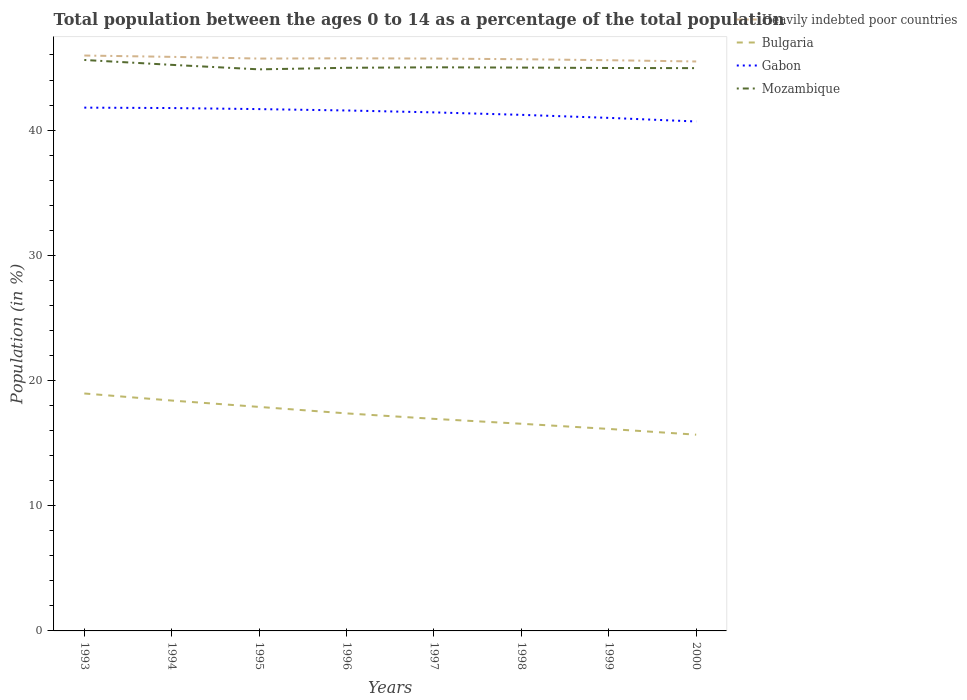How many different coloured lines are there?
Provide a short and direct response. 4. Across all years, what is the maximum percentage of the population ages 0 to 14 in Mozambique?
Your response must be concise. 44.85. In which year was the percentage of the population ages 0 to 14 in Bulgaria maximum?
Give a very brief answer. 2000. What is the total percentage of the population ages 0 to 14 in Heavily indebted poor countries in the graph?
Your answer should be very brief. 0.13. What is the difference between the highest and the second highest percentage of the population ages 0 to 14 in Heavily indebted poor countries?
Offer a very short reply. 0.47. Is the percentage of the population ages 0 to 14 in Bulgaria strictly greater than the percentage of the population ages 0 to 14 in Gabon over the years?
Give a very brief answer. Yes. What is the difference between two consecutive major ticks on the Y-axis?
Ensure brevity in your answer.  10. Are the values on the major ticks of Y-axis written in scientific E-notation?
Provide a short and direct response. No. Does the graph contain any zero values?
Provide a short and direct response. No. Does the graph contain grids?
Give a very brief answer. No. How are the legend labels stacked?
Your answer should be compact. Vertical. What is the title of the graph?
Ensure brevity in your answer.  Total population between the ages 0 to 14 as a percentage of the total population. Does "Jordan" appear as one of the legend labels in the graph?
Offer a very short reply. No. What is the Population (in %) of Heavily indebted poor countries in 1993?
Offer a terse response. 45.95. What is the Population (in %) of Bulgaria in 1993?
Offer a very short reply. 18.96. What is the Population (in %) in Gabon in 1993?
Provide a short and direct response. 41.79. What is the Population (in %) of Mozambique in 1993?
Provide a short and direct response. 45.6. What is the Population (in %) of Heavily indebted poor countries in 1994?
Ensure brevity in your answer.  45.85. What is the Population (in %) in Bulgaria in 1994?
Your answer should be compact. 18.4. What is the Population (in %) of Gabon in 1994?
Give a very brief answer. 41.76. What is the Population (in %) in Mozambique in 1994?
Provide a short and direct response. 45.21. What is the Population (in %) in Heavily indebted poor countries in 1995?
Give a very brief answer. 45.71. What is the Population (in %) of Bulgaria in 1995?
Provide a succinct answer. 17.89. What is the Population (in %) of Gabon in 1995?
Provide a short and direct response. 41.68. What is the Population (in %) of Mozambique in 1995?
Provide a short and direct response. 44.85. What is the Population (in %) of Heavily indebted poor countries in 1996?
Make the answer very short. 45.73. What is the Population (in %) of Bulgaria in 1996?
Provide a short and direct response. 17.37. What is the Population (in %) of Gabon in 1996?
Make the answer very short. 41.57. What is the Population (in %) in Mozambique in 1996?
Keep it short and to the point. 44.98. What is the Population (in %) of Heavily indebted poor countries in 1997?
Keep it short and to the point. 45.71. What is the Population (in %) of Bulgaria in 1997?
Provide a short and direct response. 16.94. What is the Population (in %) of Gabon in 1997?
Your answer should be very brief. 41.41. What is the Population (in %) of Mozambique in 1997?
Provide a short and direct response. 45.01. What is the Population (in %) of Heavily indebted poor countries in 1998?
Your response must be concise. 45.66. What is the Population (in %) of Bulgaria in 1998?
Give a very brief answer. 16.55. What is the Population (in %) in Gabon in 1998?
Provide a short and direct response. 41.22. What is the Population (in %) of Mozambique in 1998?
Make the answer very short. 44.99. What is the Population (in %) in Heavily indebted poor countries in 1999?
Offer a very short reply. 45.58. What is the Population (in %) of Bulgaria in 1999?
Keep it short and to the point. 16.13. What is the Population (in %) of Gabon in 1999?
Your answer should be compact. 40.98. What is the Population (in %) of Mozambique in 1999?
Make the answer very short. 44.96. What is the Population (in %) in Heavily indebted poor countries in 2000?
Provide a short and direct response. 45.48. What is the Population (in %) in Bulgaria in 2000?
Make the answer very short. 15.67. What is the Population (in %) of Gabon in 2000?
Your response must be concise. 40.69. What is the Population (in %) of Mozambique in 2000?
Your answer should be compact. 44.95. Across all years, what is the maximum Population (in %) of Heavily indebted poor countries?
Ensure brevity in your answer.  45.95. Across all years, what is the maximum Population (in %) in Bulgaria?
Your answer should be very brief. 18.96. Across all years, what is the maximum Population (in %) of Gabon?
Your answer should be very brief. 41.79. Across all years, what is the maximum Population (in %) in Mozambique?
Make the answer very short. 45.6. Across all years, what is the minimum Population (in %) in Heavily indebted poor countries?
Offer a very short reply. 45.48. Across all years, what is the minimum Population (in %) in Bulgaria?
Provide a short and direct response. 15.67. Across all years, what is the minimum Population (in %) of Gabon?
Offer a very short reply. 40.69. Across all years, what is the minimum Population (in %) in Mozambique?
Make the answer very short. 44.85. What is the total Population (in %) of Heavily indebted poor countries in the graph?
Provide a short and direct response. 365.68. What is the total Population (in %) of Bulgaria in the graph?
Offer a terse response. 137.91. What is the total Population (in %) in Gabon in the graph?
Give a very brief answer. 331.09. What is the total Population (in %) in Mozambique in the graph?
Give a very brief answer. 360.55. What is the difference between the Population (in %) in Heavily indebted poor countries in 1993 and that in 1994?
Offer a very short reply. 0.11. What is the difference between the Population (in %) of Bulgaria in 1993 and that in 1994?
Keep it short and to the point. 0.56. What is the difference between the Population (in %) of Gabon in 1993 and that in 1994?
Make the answer very short. 0.03. What is the difference between the Population (in %) of Mozambique in 1993 and that in 1994?
Provide a short and direct response. 0.39. What is the difference between the Population (in %) of Heavily indebted poor countries in 1993 and that in 1995?
Make the answer very short. 0.24. What is the difference between the Population (in %) of Bulgaria in 1993 and that in 1995?
Make the answer very short. 1.07. What is the difference between the Population (in %) of Gabon in 1993 and that in 1995?
Your answer should be very brief. 0.12. What is the difference between the Population (in %) in Mozambique in 1993 and that in 1995?
Offer a terse response. 0.75. What is the difference between the Population (in %) of Heavily indebted poor countries in 1993 and that in 1996?
Your response must be concise. 0.22. What is the difference between the Population (in %) in Bulgaria in 1993 and that in 1996?
Your response must be concise. 1.59. What is the difference between the Population (in %) of Gabon in 1993 and that in 1996?
Your response must be concise. 0.23. What is the difference between the Population (in %) in Mozambique in 1993 and that in 1996?
Offer a terse response. 0.62. What is the difference between the Population (in %) in Heavily indebted poor countries in 1993 and that in 1997?
Provide a short and direct response. 0.24. What is the difference between the Population (in %) in Bulgaria in 1993 and that in 1997?
Give a very brief answer. 2.03. What is the difference between the Population (in %) in Gabon in 1993 and that in 1997?
Offer a very short reply. 0.38. What is the difference between the Population (in %) of Mozambique in 1993 and that in 1997?
Keep it short and to the point. 0.59. What is the difference between the Population (in %) of Heavily indebted poor countries in 1993 and that in 1998?
Give a very brief answer. 0.29. What is the difference between the Population (in %) of Bulgaria in 1993 and that in 1998?
Ensure brevity in your answer.  2.42. What is the difference between the Population (in %) in Gabon in 1993 and that in 1998?
Your answer should be compact. 0.58. What is the difference between the Population (in %) in Mozambique in 1993 and that in 1998?
Your answer should be very brief. 0.61. What is the difference between the Population (in %) of Heavily indebted poor countries in 1993 and that in 1999?
Ensure brevity in your answer.  0.37. What is the difference between the Population (in %) of Bulgaria in 1993 and that in 1999?
Ensure brevity in your answer.  2.83. What is the difference between the Population (in %) of Gabon in 1993 and that in 1999?
Your answer should be compact. 0.82. What is the difference between the Population (in %) in Mozambique in 1993 and that in 1999?
Offer a terse response. 0.64. What is the difference between the Population (in %) in Heavily indebted poor countries in 1993 and that in 2000?
Ensure brevity in your answer.  0.47. What is the difference between the Population (in %) in Bulgaria in 1993 and that in 2000?
Your answer should be compact. 3.29. What is the difference between the Population (in %) in Gabon in 1993 and that in 2000?
Give a very brief answer. 1.11. What is the difference between the Population (in %) of Mozambique in 1993 and that in 2000?
Offer a terse response. 0.65. What is the difference between the Population (in %) in Heavily indebted poor countries in 1994 and that in 1995?
Offer a very short reply. 0.14. What is the difference between the Population (in %) in Bulgaria in 1994 and that in 1995?
Your response must be concise. 0.51. What is the difference between the Population (in %) of Gabon in 1994 and that in 1995?
Your response must be concise. 0.08. What is the difference between the Population (in %) of Mozambique in 1994 and that in 1995?
Offer a terse response. 0.36. What is the difference between the Population (in %) of Heavily indebted poor countries in 1994 and that in 1996?
Offer a very short reply. 0.12. What is the difference between the Population (in %) of Bulgaria in 1994 and that in 1996?
Provide a succinct answer. 1.03. What is the difference between the Population (in %) in Gabon in 1994 and that in 1996?
Your answer should be very brief. 0.19. What is the difference between the Population (in %) of Mozambique in 1994 and that in 1996?
Offer a terse response. 0.23. What is the difference between the Population (in %) of Heavily indebted poor countries in 1994 and that in 1997?
Offer a very short reply. 0.14. What is the difference between the Population (in %) in Bulgaria in 1994 and that in 1997?
Provide a short and direct response. 1.46. What is the difference between the Population (in %) of Gabon in 1994 and that in 1997?
Your response must be concise. 0.35. What is the difference between the Population (in %) of Mozambique in 1994 and that in 1997?
Your answer should be very brief. 0.2. What is the difference between the Population (in %) of Heavily indebted poor countries in 1994 and that in 1998?
Offer a very short reply. 0.19. What is the difference between the Population (in %) of Bulgaria in 1994 and that in 1998?
Provide a succinct answer. 1.85. What is the difference between the Population (in %) in Gabon in 1994 and that in 1998?
Offer a very short reply. 0.54. What is the difference between the Population (in %) in Mozambique in 1994 and that in 1998?
Your answer should be very brief. 0.22. What is the difference between the Population (in %) of Heavily indebted poor countries in 1994 and that in 1999?
Your answer should be compact. 0.27. What is the difference between the Population (in %) of Bulgaria in 1994 and that in 1999?
Ensure brevity in your answer.  2.27. What is the difference between the Population (in %) of Gabon in 1994 and that in 1999?
Offer a terse response. 0.79. What is the difference between the Population (in %) of Mozambique in 1994 and that in 1999?
Your answer should be very brief. 0.25. What is the difference between the Population (in %) in Heavily indebted poor countries in 1994 and that in 2000?
Make the answer very short. 0.37. What is the difference between the Population (in %) of Bulgaria in 1994 and that in 2000?
Offer a very short reply. 2.73. What is the difference between the Population (in %) of Gabon in 1994 and that in 2000?
Provide a succinct answer. 1.07. What is the difference between the Population (in %) of Mozambique in 1994 and that in 2000?
Your answer should be compact. 0.26. What is the difference between the Population (in %) of Heavily indebted poor countries in 1995 and that in 1996?
Provide a succinct answer. -0.02. What is the difference between the Population (in %) of Bulgaria in 1995 and that in 1996?
Offer a terse response. 0.52. What is the difference between the Population (in %) of Gabon in 1995 and that in 1996?
Your answer should be very brief. 0.11. What is the difference between the Population (in %) in Mozambique in 1995 and that in 1996?
Your answer should be very brief. -0.12. What is the difference between the Population (in %) in Heavily indebted poor countries in 1995 and that in 1997?
Keep it short and to the point. -0. What is the difference between the Population (in %) in Bulgaria in 1995 and that in 1997?
Your answer should be compact. 0.95. What is the difference between the Population (in %) of Gabon in 1995 and that in 1997?
Your response must be concise. 0.26. What is the difference between the Population (in %) in Mozambique in 1995 and that in 1997?
Offer a very short reply. -0.16. What is the difference between the Population (in %) of Heavily indebted poor countries in 1995 and that in 1998?
Ensure brevity in your answer.  0.05. What is the difference between the Population (in %) in Bulgaria in 1995 and that in 1998?
Your answer should be compact. 1.35. What is the difference between the Population (in %) in Gabon in 1995 and that in 1998?
Give a very brief answer. 0.46. What is the difference between the Population (in %) of Mozambique in 1995 and that in 1998?
Give a very brief answer. -0.14. What is the difference between the Population (in %) of Heavily indebted poor countries in 1995 and that in 1999?
Make the answer very short. 0.13. What is the difference between the Population (in %) in Bulgaria in 1995 and that in 1999?
Your response must be concise. 1.76. What is the difference between the Population (in %) of Gabon in 1995 and that in 1999?
Ensure brevity in your answer.  0.7. What is the difference between the Population (in %) in Mozambique in 1995 and that in 1999?
Make the answer very short. -0.11. What is the difference between the Population (in %) in Heavily indebted poor countries in 1995 and that in 2000?
Your response must be concise. 0.23. What is the difference between the Population (in %) in Bulgaria in 1995 and that in 2000?
Your response must be concise. 2.22. What is the difference between the Population (in %) in Gabon in 1995 and that in 2000?
Provide a short and direct response. 0.99. What is the difference between the Population (in %) in Mozambique in 1995 and that in 2000?
Offer a terse response. -0.1. What is the difference between the Population (in %) in Heavily indebted poor countries in 1996 and that in 1997?
Your response must be concise. 0.02. What is the difference between the Population (in %) in Bulgaria in 1996 and that in 1997?
Make the answer very short. 0.44. What is the difference between the Population (in %) in Gabon in 1996 and that in 1997?
Offer a very short reply. 0.15. What is the difference between the Population (in %) of Mozambique in 1996 and that in 1997?
Provide a succinct answer. -0.04. What is the difference between the Population (in %) of Heavily indebted poor countries in 1996 and that in 1998?
Offer a very short reply. 0.07. What is the difference between the Population (in %) of Bulgaria in 1996 and that in 1998?
Provide a short and direct response. 0.83. What is the difference between the Population (in %) in Gabon in 1996 and that in 1998?
Your answer should be compact. 0.35. What is the difference between the Population (in %) of Mozambique in 1996 and that in 1998?
Provide a succinct answer. -0.02. What is the difference between the Population (in %) of Heavily indebted poor countries in 1996 and that in 1999?
Provide a short and direct response. 0.15. What is the difference between the Population (in %) of Bulgaria in 1996 and that in 1999?
Make the answer very short. 1.24. What is the difference between the Population (in %) in Gabon in 1996 and that in 1999?
Your answer should be compact. 0.59. What is the difference between the Population (in %) in Mozambique in 1996 and that in 1999?
Offer a terse response. 0.02. What is the difference between the Population (in %) of Heavily indebted poor countries in 1996 and that in 2000?
Provide a succinct answer. 0.25. What is the difference between the Population (in %) of Bulgaria in 1996 and that in 2000?
Give a very brief answer. 1.7. What is the difference between the Population (in %) of Gabon in 1996 and that in 2000?
Offer a very short reply. 0.88. What is the difference between the Population (in %) in Mozambique in 1996 and that in 2000?
Provide a succinct answer. 0.03. What is the difference between the Population (in %) in Heavily indebted poor countries in 1997 and that in 1998?
Your answer should be very brief. 0.05. What is the difference between the Population (in %) of Bulgaria in 1997 and that in 1998?
Keep it short and to the point. 0.39. What is the difference between the Population (in %) in Gabon in 1997 and that in 1998?
Provide a succinct answer. 0.2. What is the difference between the Population (in %) in Mozambique in 1997 and that in 1998?
Make the answer very short. 0.02. What is the difference between the Population (in %) of Heavily indebted poor countries in 1997 and that in 1999?
Your answer should be compact. 0.13. What is the difference between the Population (in %) in Bulgaria in 1997 and that in 1999?
Provide a succinct answer. 0.8. What is the difference between the Population (in %) in Gabon in 1997 and that in 1999?
Your response must be concise. 0.44. What is the difference between the Population (in %) of Mozambique in 1997 and that in 1999?
Ensure brevity in your answer.  0.05. What is the difference between the Population (in %) in Heavily indebted poor countries in 1997 and that in 2000?
Keep it short and to the point. 0.23. What is the difference between the Population (in %) of Bulgaria in 1997 and that in 2000?
Provide a succinct answer. 1.26. What is the difference between the Population (in %) of Gabon in 1997 and that in 2000?
Your response must be concise. 0.73. What is the difference between the Population (in %) in Mozambique in 1997 and that in 2000?
Offer a very short reply. 0.07. What is the difference between the Population (in %) in Heavily indebted poor countries in 1998 and that in 1999?
Offer a very short reply. 0.08. What is the difference between the Population (in %) in Bulgaria in 1998 and that in 1999?
Give a very brief answer. 0.41. What is the difference between the Population (in %) of Gabon in 1998 and that in 1999?
Your response must be concise. 0.24. What is the difference between the Population (in %) of Mozambique in 1998 and that in 1999?
Offer a terse response. 0.03. What is the difference between the Population (in %) of Heavily indebted poor countries in 1998 and that in 2000?
Offer a very short reply. 0.18. What is the difference between the Population (in %) of Bulgaria in 1998 and that in 2000?
Give a very brief answer. 0.87. What is the difference between the Population (in %) in Gabon in 1998 and that in 2000?
Your response must be concise. 0.53. What is the difference between the Population (in %) in Mozambique in 1998 and that in 2000?
Your response must be concise. 0.04. What is the difference between the Population (in %) of Heavily indebted poor countries in 1999 and that in 2000?
Offer a terse response. 0.1. What is the difference between the Population (in %) of Bulgaria in 1999 and that in 2000?
Ensure brevity in your answer.  0.46. What is the difference between the Population (in %) in Gabon in 1999 and that in 2000?
Offer a terse response. 0.29. What is the difference between the Population (in %) of Mozambique in 1999 and that in 2000?
Give a very brief answer. 0.01. What is the difference between the Population (in %) in Heavily indebted poor countries in 1993 and the Population (in %) in Bulgaria in 1994?
Make the answer very short. 27.56. What is the difference between the Population (in %) in Heavily indebted poor countries in 1993 and the Population (in %) in Gabon in 1994?
Your answer should be compact. 4.19. What is the difference between the Population (in %) in Heavily indebted poor countries in 1993 and the Population (in %) in Mozambique in 1994?
Ensure brevity in your answer.  0.75. What is the difference between the Population (in %) of Bulgaria in 1993 and the Population (in %) of Gabon in 1994?
Your answer should be compact. -22.8. What is the difference between the Population (in %) in Bulgaria in 1993 and the Population (in %) in Mozambique in 1994?
Your answer should be very brief. -26.25. What is the difference between the Population (in %) of Gabon in 1993 and the Population (in %) of Mozambique in 1994?
Your answer should be very brief. -3.42. What is the difference between the Population (in %) in Heavily indebted poor countries in 1993 and the Population (in %) in Bulgaria in 1995?
Give a very brief answer. 28.06. What is the difference between the Population (in %) of Heavily indebted poor countries in 1993 and the Population (in %) of Gabon in 1995?
Provide a short and direct response. 4.28. What is the difference between the Population (in %) of Heavily indebted poor countries in 1993 and the Population (in %) of Mozambique in 1995?
Your response must be concise. 1.1. What is the difference between the Population (in %) of Bulgaria in 1993 and the Population (in %) of Gabon in 1995?
Ensure brevity in your answer.  -22.71. What is the difference between the Population (in %) of Bulgaria in 1993 and the Population (in %) of Mozambique in 1995?
Your response must be concise. -25.89. What is the difference between the Population (in %) in Gabon in 1993 and the Population (in %) in Mozambique in 1995?
Give a very brief answer. -3.06. What is the difference between the Population (in %) of Heavily indebted poor countries in 1993 and the Population (in %) of Bulgaria in 1996?
Give a very brief answer. 28.58. What is the difference between the Population (in %) of Heavily indebted poor countries in 1993 and the Population (in %) of Gabon in 1996?
Make the answer very short. 4.39. What is the difference between the Population (in %) in Heavily indebted poor countries in 1993 and the Population (in %) in Mozambique in 1996?
Keep it short and to the point. 0.98. What is the difference between the Population (in %) of Bulgaria in 1993 and the Population (in %) of Gabon in 1996?
Provide a succinct answer. -22.6. What is the difference between the Population (in %) in Bulgaria in 1993 and the Population (in %) in Mozambique in 1996?
Offer a very short reply. -26.01. What is the difference between the Population (in %) in Gabon in 1993 and the Population (in %) in Mozambique in 1996?
Keep it short and to the point. -3.18. What is the difference between the Population (in %) of Heavily indebted poor countries in 1993 and the Population (in %) of Bulgaria in 1997?
Give a very brief answer. 29.02. What is the difference between the Population (in %) of Heavily indebted poor countries in 1993 and the Population (in %) of Gabon in 1997?
Offer a very short reply. 4.54. What is the difference between the Population (in %) in Heavily indebted poor countries in 1993 and the Population (in %) in Mozambique in 1997?
Your response must be concise. 0.94. What is the difference between the Population (in %) in Bulgaria in 1993 and the Population (in %) in Gabon in 1997?
Make the answer very short. -22.45. What is the difference between the Population (in %) of Bulgaria in 1993 and the Population (in %) of Mozambique in 1997?
Ensure brevity in your answer.  -26.05. What is the difference between the Population (in %) in Gabon in 1993 and the Population (in %) in Mozambique in 1997?
Provide a succinct answer. -3.22. What is the difference between the Population (in %) of Heavily indebted poor countries in 1993 and the Population (in %) of Bulgaria in 1998?
Your response must be concise. 29.41. What is the difference between the Population (in %) of Heavily indebted poor countries in 1993 and the Population (in %) of Gabon in 1998?
Provide a short and direct response. 4.74. What is the difference between the Population (in %) of Heavily indebted poor countries in 1993 and the Population (in %) of Mozambique in 1998?
Provide a short and direct response. 0.96. What is the difference between the Population (in %) in Bulgaria in 1993 and the Population (in %) in Gabon in 1998?
Offer a very short reply. -22.25. What is the difference between the Population (in %) in Bulgaria in 1993 and the Population (in %) in Mozambique in 1998?
Your response must be concise. -26.03. What is the difference between the Population (in %) in Gabon in 1993 and the Population (in %) in Mozambique in 1998?
Make the answer very short. -3.2. What is the difference between the Population (in %) of Heavily indebted poor countries in 1993 and the Population (in %) of Bulgaria in 1999?
Offer a terse response. 29.82. What is the difference between the Population (in %) in Heavily indebted poor countries in 1993 and the Population (in %) in Gabon in 1999?
Make the answer very short. 4.98. What is the difference between the Population (in %) in Bulgaria in 1993 and the Population (in %) in Gabon in 1999?
Make the answer very short. -22.01. What is the difference between the Population (in %) of Bulgaria in 1993 and the Population (in %) of Mozambique in 1999?
Offer a terse response. -26. What is the difference between the Population (in %) of Gabon in 1993 and the Population (in %) of Mozambique in 1999?
Offer a very short reply. -3.17. What is the difference between the Population (in %) in Heavily indebted poor countries in 1993 and the Population (in %) in Bulgaria in 2000?
Offer a very short reply. 30.28. What is the difference between the Population (in %) in Heavily indebted poor countries in 1993 and the Population (in %) in Gabon in 2000?
Give a very brief answer. 5.27. What is the difference between the Population (in %) of Heavily indebted poor countries in 1993 and the Population (in %) of Mozambique in 2000?
Ensure brevity in your answer.  1.01. What is the difference between the Population (in %) of Bulgaria in 1993 and the Population (in %) of Gabon in 2000?
Offer a very short reply. -21.72. What is the difference between the Population (in %) in Bulgaria in 1993 and the Population (in %) in Mozambique in 2000?
Your response must be concise. -25.98. What is the difference between the Population (in %) in Gabon in 1993 and the Population (in %) in Mozambique in 2000?
Offer a very short reply. -3.15. What is the difference between the Population (in %) of Heavily indebted poor countries in 1994 and the Population (in %) of Bulgaria in 1995?
Offer a very short reply. 27.96. What is the difference between the Population (in %) of Heavily indebted poor countries in 1994 and the Population (in %) of Gabon in 1995?
Ensure brevity in your answer.  4.17. What is the difference between the Population (in %) in Heavily indebted poor countries in 1994 and the Population (in %) in Mozambique in 1995?
Offer a terse response. 1. What is the difference between the Population (in %) in Bulgaria in 1994 and the Population (in %) in Gabon in 1995?
Your answer should be very brief. -23.28. What is the difference between the Population (in %) of Bulgaria in 1994 and the Population (in %) of Mozambique in 1995?
Give a very brief answer. -26.45. What is the difference between the Population (in %) in Gabon in 1994 and the Population (in %) in Mozambique in 1995?
Ensure brevity in your answer.  -3.09. What is the difference between the Population (in %) of Heavily indebted poor countries in 1994 and the Population (in %) of Bulgaria in 1996?
Make the answer very short. 28.48. What is the difference between the Population (in %) in Heavily indebted poor countries in 1994 and the Population (in %) in Gabon in 1996?
Make the answer very short. 4.28. What is the difference between the Population (in %) of Heavily indebted poor countries in 1994 and the Population (in %) of Mozambique in 1996?
Your answer should be very brief. 0.87. What is the difference between the Population (in %) in Bulgaria in 1994 and the Population (in %) in Gabon in 1996?
Provide a short and direct response. -23.17. What is the difference between the Population (in %) of Bulgaria in 1994 and the Population (in %) of Mozambique in 1996?
Give a very brief answer. -26.58. What is the difference between the Population (in %) of Gabon in 1994 and the Population (in %) of Mozambique in 1996?
Your response must be concise. -3.22. What is the difference between the Population (in %) of Heavily indebted poor countries in 1994 and the Population (in %) of Bulgaria in 1997?
Provide a short and direct response. 28.91. What is the difference between the Population (in %) of Heavily indebted poor countries in 1994 and the Population (in %) of Gabon in 1997?
Make the answer very short. 4.43. What is the difference between the Population (in %) in Heavily indebted poor countries in 1994 and the Population (in %) in Mozambique in 1997?
Give a very brief answer. 0.83. What is the difference between the Population (in %) in Bulgaria in 1994 and the Population (in %) in Gabon in 1997?
Provide a short and direct response. -23.02. What is the difference between the Population (in %) of Bulgaria in 1994 and the Population (in %) of Mozambique in 1997?
Offer a very short reply. -26.62. What is the difference between the Population (in %) in Gabon in 1994 and the Population (in %) in Mozambique in 1997?
Your response must be concise. -3.25. What is the difference between the Population (in %) of Heavily indebted poor countries in 1994 and the Population (in %) of Bulgaria in 1998?
Offer a terse response. 29.3. What is the difference between the Population (in %) in Heavily indebted poor countries in 1994 and the Population (in %) in Gabon in 1998?
Offer a very short reply. 4.63. What is the difference between the Population (in %) in Heavily indebted poor countries in 1994 and the Population (in %) in Mozambique in 1998?
Give a very brief answer. 0.86. What is the difference between the Population (in %) of Bulgaria in 1994 and the Population (in %) of Gabon in 1998?
Your answer should be compact. -22.82. What is the difference between the Population (in %) of Bulgaria in 1994 and the Population (in %) of Mozambique in 1998?
Ensure brevity in your answer.  -26.59. What is the difference between the Population (in %) of Gabon in 1994 and the Population (in %) of Mozambique in 1998?
Ensure brevity in your answer.  -3.23. What is the difference between the Population (in %) of Heavily indebted poor countries in 1994 and the Population (in %) of Bulgaria in 1999?
Your answer should be compact. 29.72. What is the difference between the Population (in %) of Heavily indebted poor countries in 1994 and the Population (in %) of Gabon in 1999?
Your answer should be very brief. 4.87. What is the difference between the Population (in %) in Heavily indebted poor countries in 1994 and the Population (in %) in Mozambique in 1999?
Your response must be concise. 0.89. What is the difference between the Population (in %) in Bulgaria in 1994 and the Population (in %) in Gabon in 1999?
Keep it short and to the point. -22.58. What is the difference between the Population (in %) of Bulgaria in 1994 and the Population (in %) of Mozambique in 1999?
Your response must be concise. -26.56. What is the difference between the Population (in %) in Gabon in 1994 and the Population (in %) in Mozambique in 1999?
Your answer should be very brief. -3.2. What is the difference between the Population (in %) in Heavily indebted poor countries in 1994 and the Population (in %) in Bulgaria in 2000?
Provide a succinct answer. 30.18. What is the difference between the Population (in %) in Heavily indebted poor countries in 1994 and the Population (in %) in Gabon in 2000?
Offer a very short reply. 5.16. What is the difference between the Population (in %) in Heavily indebted poor countries in 1994 and the Population (in %) in Mozambique in 2000?
Your answer should be compact. 0.9. What is the difference between the Population (in %) in Bulgaria in 1994 and the Population (in %) in Gabon in 2000?
Provide a short and direct response. -22.29. What is the difference between the Population (in %) of Bulgaria in 1994 and the Population (in %) of Mozambique in 2000?
Your answer should be very brief. -26.55. What is the difference between the Population (in %) of Gabon in 1994 and the Population (in %) of Mozambique in 2000?
Provide a short and direct response. -3.19. What is the difference between the Population (in %) of Heavily indebted poor countries in 1995 and the Population (in %) of Bulgaria in 1996?
Your answer should be very brief. 28.34. What is the difference between the Population (in %) of Heavily indebted poor countries in 1995 and the Population (in %) of Gabon in 1996?
Your response must be concise. 4.15. What is the difference between the Population (in %) of Heavily indebted poor countries in 1995 and the Population (in %) of Mozambique in 1996?
Make the answer very short. 0.74. What is the difference between the Population (in %) of Bulgaria in 1995 and the Population (in %) of Gabon in 1996?
Offer a terse response. -23.68. What is the difference between the Population (in %) in Bulgaria in 1995 and the Population (in %) in Mozambique in 1996?
Give a very brief answer. -27.08. What is the difference between the Population (in %) of Gabon in 1995 and the Population (in %) of Mozambique in 1996?
Offer a very short reply. -3.3. What is the difference between the Population (in %) in Heavily indebted poor countries in 1995 and the Population (in %) in Bulgaria in 1997?
Offer a very short reply. 28.78. What is the difference between the Population (in %) in Heavily indebted poor countries in 1995 and the Population (in %) in Gabon in 1997?
Provide a succinct answer. 4.3. What is the difference between the Population (in %) in Heavily indebted poor countries in 1995 and the Population (in %) in Mozambique in 1997?
Offer a terse response. 0.7. What is the difference between the Population (in %) of Bulgaria in 1995 and the Population (in %) of Gabon in 1997?
Your answer should be compact. -23.52. What is the difference between the Population (in %) of Bulgaria in 1995 and the Population (in %) of Mozambique in 1997?
Your answer should be very brief. -27.12. What is the difference between the Population (in %) of Gabon in 1995 and the Population (in %) of Mozambique in 1997?
Your response must be concise. -3.34. What is the difference between the Population (in %) of Heavily indebted poor countries in 1995 and the Population (in %) of Bulgaria in 1998?
Your answer should be very brief. 29.17. What is the difference between the Population (in %) of Heavily indebted poor countries in 1995 and the Population (in %) of Gabon in 1998?
Your answer should be compact. 4.5. What is the difference between the Population (in %) in Heavily indebted poor countries in 1995 and the Population (in %) in Mozambique in 1998?
Offer a terse response. 0.72. What is the difference between the Population (in %) in Bulgaria in 1995 and the Population (in %) in Gabon in 1998?
Ensure brevity in your answer.  -23.33. What is the difference between the Population (in %) in Bulgaria in 1995 and the Population (in %) in Mozambique in 1998?
Provide a succinct answer. -27.1. What is the difference between the Population (in %) in Gabon in 1995 and the Population (in %) in Mozambique in 1998?
Make the answer very short. -3.32. What is the difference between the Population (in %) in Heavily indebted poor countries in 1995 and the Population (in %) in Bulgaria in 1999?
Give a very brief answer. 29.58. What is the difference between the Population (in %) in Heavily indebted poor countries in 1995 and the Population (in %) in Gabon in 1999?
Your response must be concise. 4.74. What is the difference between the Population (in %) of Heavily indebted poor countries in 1995 and the Population (in %) of Mozambique in 1999?
Provide a succinct answer. 0.75. What is the difference between the Population (in %) of Bulgaria in 1995 and the Population (in %) of Gabon in 1999?
Provide a short and direct response. -23.08. What is the difference between the Population (in %) in Bulgaria in 1995 and the Population (in %) in Mozambique in 1999?
Your answer should be compact. -27.07. What is the difference between the Population (in %) of Gabon in 1995 and the Population (in %) of Mozambique in 1999?
Provide a succinct answer. -3.28. What is the difference between the Population (in %) of Heavily indebted poor countries in 1995 and the Population (in %) of Bulgaria in 2000?
Give a very brief answer. 30.04. What is the difference between the Population (in %) of Heavily indebted poor countries in 1995 and the Population (in %) of Gabon in 2000?
Offer a terse response. 5.03. What is the difference between the Population (in %) of Heavily indebted poor countries in 1995 and the Population (in %) of Mozambique in 2000?
Provide a short and direct response. 0.76. What is the difference between the Population (in %) in Bulgaria in 1995 and the Population (in %) in Gabon in 2000?
Provide a short and direct response. -22.8. What is the difference between the Population (in %) of Bulgaria in 1995 and the Population (in %) of Mozambique in 2000?
Your answer should be compact. -27.06. What is the difference between the Population (in %) in Gabon in 1995 and the Population (in %) in Mozambique in 2000?
Make the answer very short. -3.27. What is the difference between the Population (in %) in Heavily indebted poor countries in 1996 and the Population (in %) in Bulgaria in 1997?
Give a very brief answer. 28.8. What is the difference between the Population (in %) in Heavily indebted poor countries in 1996 and the Population (in %) in Gabon in 1997?
Provide a succinct answer. 4.32. What is the difference between the Population (in %) of Heavily indebted poor countries in 1996 and the Population (in %) of Mozambique in 1997?
Make the answer very short. 0.72. What is the difference between the Population (in %) in Bulgaria in 1996 and the Population (in %) in Gabon in 1997?
Your answer should be compact. -24.04. What is the difference between the Population (in %) of Bulgaria in 1996 and the Population (in %) of Mozambique in 1997?
Your answer should be very brief. -27.64. What is the difference between the Population (in %) of Gabon in 1996 and the Population (in %) of Mozambique in 1997?
Ensure brevity in your answer.  -3.45. What is the difference between the Population (in %) in Heavily indebted poor countries in 1996 and the Population (in %) in Bulgaria in 1998?
Provide a succinct answer. 29.19. What is the difference between the Population (in %) in Heavily indebted poor countries in 1996 and the Population (in %) in Gabon in 1998?
Make the answer very short. 4.52. What is the difference between the Population (in %) of Heavily indebted poor countries in 1996 and the Population (in %) of Mozambique in 1998?
Your response must be concise. 0.74. What is the difference between the Population (in %) in Bulgaria in 1996 and the Population (in %) in Gabon in 1998?
Offer a terse response. -23.84. What is the difference between the Population (in %) in Bulgaria in 1996 and the Population (in %) in Mozambique in 1998?
Provide a succinct answer. -27.62. What is the difference between the Population (in %) in Gabon in 1996 and the Population (in %) in Mozambique in 1998?
Make the answer very short. -3.43. What is the difference between the Population (in %) of Heavily indebted poor countries in 1996 and the Population (in %) of Bulgaria in 1999?
Provide a short and direct response. 29.6. What is the difference between the Population (in %) in Heavily indebted poor countries in 1996 and the Population (in %) in Gabon in 1999?
Ensure brevity in your answer.  4.76. What is the difference between the Population (in %) of Heavily indebted poor countries in 1996 and the Population (in %) of Mozambique in 1999?
Keep it short and to the point. 0.77. What is the difference between the Population (in %) of Bulgaria in 1996 and the Population (in %) of Gabon in 1999?
Keep it short and to the point. -23.6. What is the difference between the Population (in %) of Bulgaria in 1996 and the Population (in %) of Mozambique in 1999?
Provide a short and direct response. -27.59. What is the difference between the Population (in %) in Gabon in 1996 and the Population (in %) in Mozambique in 1999?
Offer a very short reply. -3.39. What is the difference between the Population (in %) of Heavily indebted poor countries in 1996 and the Population (in %) of Bulgaria in 2000?
Offer a very short reply. 30.06. What is the difference between the Population (in %) of Heavily indebted poor countries in 1996 and the Population (in %) of Gabon in 2000?
Keep it short and to the point. 5.05. What is the difference between the Population (in %) in Heavily indebted poor countries in 1996 and the Population (in %) in Mozambique in 2000?
Your answer should be very brief. 0.79. What is the difference between the Population (in %) in Bulgaria in 1996 and the Population (in %) in Gabon in 2000?
Offer a very short reply. -23.31. What is the difference between the Population (in %) of Bulgaria in 1996 and the Population (in %) of Mozambique in 2000?
Your answer should be very brief. -27.57. What is the difference between the Population (in %) of Gabon in 1996 and the Population (in %) of Mozambique in 2000?
Provide a short and direct response. -3.38. What is the difference between the Population (in %) in Heavily indebted poor countries in 1997 and the Population (in %) in Bulgaria in 1998?
Provide a short and direct response. 29.17. What is the difference between the Population (in %) of Heavily indebted poor countries in 1997 and the Population (in %) of Gabon in 1998?
Offer a very short reply. 4.5. What is the difference between the Population (in %) in Heavily indebted poor countries in 1997 and the Population (in %) in Mozambique in 1998?
Provide a short and direct response. 0.72. What is the difference between the Population (in %) in Bulgaria in 1997 and the Population (in %) in Gabon in 1998?
Offer a very short reply. -24.28. What is the difference between the Population (in %) in Bulgaria in 1997 and the Population (in %) in Mozambique in 1998?
Your answer should be compact. -28.06. What is the difference between the Population (in %) of Gabon in 1997 and the Population (in %) of Mozambique in 1998?
Offer a terse response. -3.58. What is the difference between the Population (in %) in Heavily indebted poor countries in 1997 and the Population (in %) in Bulgaria in 1999?
Ensure brevity in your answer.  29.58. What is the difference between the Population (in %) of Heavily indebted poor countries in 1997 and the Population (in %) of Gabon in 1999?
Provide a succinct answer. 4.74. What is the difference between the Population (in %) in Heavily indebted poor countries in 1997 and the Population (in %) in Mozambique in 1999?
Your answer should be compact. 0.75. What is the difference between the Population (in %) in Bulgaria in 1997 and the Population (in %) in Gabon in 1999?
Offer a terse response. -24.04. What is the difference between the Population (in %) of Bulgaria in 1997 and the Population (in %) of Mozambique in 1999?
Offer a terse response. -28.02. What is the difference between the Population (in %) of Gabon in 1997 and the Population (in %) of Mozambique in 1999?
Your answer should be compact. -3.55. What is the difference between the Population (in %) of Heavily indebted poor countries in 1997 and the Population (in %) of Bulgaria in 2000?
Make the answer very short. 30.04. What is the difference between the Population (in %) of Heavily indebted poor countries in 1997 and the Population (in %) of Gabon in 2000?
Your answer should be compact. 5.03. What is the difference between the Population (in %) in Heavily indebted poor countries in 1997 and the Population (in %) in Mozambique in 2000?
Provide a short and direct response. 0.77. What is the difference between the Population (in %) of Bulgaria in 1997 and the Population (in %) of Gabon in 2000?
Your answer should be compact. -23.75. What is the difference between the Population (in %) of Bulgaria in 1997 and the Population (in %) of Mozambique in 2000?
Keep it short and to the point. -28.01. What is the difference between the Population (in %) of Gabon in 1997 and the Population (in %) of Mozambique in 2000?
Your answer should be very brief. -3.53. What is the difference between the Population (in %) of Heavily indebted poor countries in 1998 and the Population (in %) of Bulgaria in 1999?
Your answer should be very brief. 29.53. What is the difference between the Population (in %) in Heavily indebted poor countries in 1998 and the Population (in %) in Gabon in 1999?
Your answer should be compact. 4.68. What is the difference between the Population (in %) in Heavily indebted poor countries in 1998 and the Population (in %) in Mozambique in 1999?
Keep it short and to the point. 0.7. What is the difference between the Population (in %) of Bulgaria in 1998 and the Population (in %) of Gabon in 1999?
Provide a succinct answer. -24.43. What is the difference between the Population (in %) in Bulgaria in 1998 and the Population (in %) in Mozambique in 1999?
Keep it short and to the point. -28.41. What is the difference between the Population (in %) of Gabon in 1998 and the Population (in %) of Mozambique in 1999?
Keep it short and to the point. -3.74. What is the difference between the Population (in %) of Heavily indebted poor countries in 1998 and the Population (in %) of Bulgaria in 2000?
Offer a very short reply. 29.99. What is the difference between the Population (in %) of Heavily indebted poor countries in 1998 and the Population (in %) of Gabon in 2000?
Provide a succinct answer. 4.97. What is the difference between the Population (in %) in Heavily indebted poor countries in 1998 and the Population (in %) in Mozambique in 2000?
Your response must be concise. 0.71. What is the difference between the Population (in %) of Bulgaria in 1998 and the Population (in %) of Gabon in 2000?
Give a very brief answer. -24.14. What is the difference between the Population (in %) of Bulgaria in 1998 and the Population (in %) of Mozambique in 2000?
Your response must be concise. -28.4. What is the difference between the Population (in %) in Gabon in 1998 and the Population (in %) in Mozambique in 2000?
Offer a very short reply. -3.73. What is the difference between the Population (in %) of Heavily indebted poor countries in 1999 and the Population (in %) of Bulgaria in 2000?
Keep it short and to the point. 29.91. What is the difference between the Population (in %) in Heavily indebted poor countries in 1999 and the Population (in %) in Gabon in 2000?
Ensure brevity in your answer.  4.89. What is the difference between the Population (in %) of Heavily indebted poor countries in 1999 and the Population (in %) of Mozambique in 2000?
Offer a terse response. 0.63. What is the difference between the Population (in %) in Bulgaria in 1999 and the Population (in %) in Gabon in 2000?
Provide a short and direct response. -24.56. What is the difference between the Population (in %) in Bulgaria in 1999 and the Population (in %) in Mozambique in 2000?
Your answer should be compact. -28.82. What is the difference between the Population (in %) in Gabon in 1999 and the Population (in %) in Mozambique in 2000?
Provide a short and direct response. -3.97. What is the average Population (in %) in Heavily indebted poor countries per year?
Offer a very short reply. 45.71. What is the average Population (in %) in Bulgaria per year?
Offer a terse response. 17.24. What is the average Population (in %) in Gabon per year?
Give a very brief answer. 41.39. What is the average Population (in %) in Mozambique per year?
Your answer should be compact. 45.07. In the year 1993, what is the difference between the Population (in %) in Heavily indebted poor countries and Population (in %) in Bulgaria?
Your response must be concise. 26.99. In the year 1993, what is the difference between the Population (in %) in Heavily indebted poor countries and Population (in %) in Gabon?
Offer a terse response. 4.16. In the year 1993, what is the difference between the Population (in %) in Heavily indebted poor countries and Population (in %) in Mozambique?
Your answer should be compact. 0.35. In the year 1993, what is the difference between the Population (in %) in Bulgaria and Population (in %) in Gabon?
Ensure brevity in your answer.  -22.83. In the year 1993, what is the difference between the Population (in %) in Bulgaria and Population (in %) in Mozambique?
Ensure brevity in your answer.  -26.64. In the year 1993, what is the difference between the Population (in %) in Gabon and Population (in %) in Mozambique?
Your response must be concise. -3.81. In the year 1994, what is the difference between the Population (in %) of Heavily indebted poor countries and Population (in %) of Bulgaria?
Provide a short and direct response. 27.45. In the year 1994, what is the difference between the Population (in %) of Heavily indebted poor countries and Population (in %) of Gabon?
Offer a terse response. 4.09. In the year 1994, what is the difference between the Population (in %) of Heavily indebted poor countries and Population (in %) of Mozambique?
Provide a short and direct response. 0.64. In the year 1994, what is the difference between the Population (in %) of Bulgaria and Population (in %) of Gabon?
Make the answer very short. -23.36. In the year 1994, what is the difference between the Population (in %) in Bulgaria and Population (in %) in Mozambique?
Provide a short and direct response. -26.81. In the year 1994, what is the difference between the Population (in %) of Gabon and Population (in %) of Mozambique?
Offer a very short reply. -3.45. In the year 1995, what is the difference between the Population (in %) of Heavily indebted poor countries and Population (in %) of Bulgaria?
Provide a succinct answer. 27.82. In the year 1995, what is the difference between the Population (in %) in Heavily indebted poor countries and Population (in %) in Gabon?
Offer a terse response. 4.04. In the year 1995, what is the difference between the Population (in %) in Heavily indebted poor countries and Population (in %) in Mozambique?
Keep it short and to the point. 0.86. In the year 1995, what is the difference between the Population (in %) of Bulgaria and Population (in %) of Gabon?
Keep it short and to the point. -23.79. In the year 1995, what is the difference between the Population (in %) in Bulgaria and Population (in %) in Mozambique?
Your response must be concise. -26.96. In the year 1995, what is the difference between the Population (in %) of Gabon and Population (in %) of Mozambique?
Offer a very short reply. -3.17. In the year 1996, what is the difference between the Population (in %) of Heavily indebted poor countries and Population (in %) of Bulgaria?
Keep it short and to the point. 28.36. In the year 1996, what is the difference between the Population (in %) of Heavily indebted poor countries and Population (in %) of Gabon?
Provide a succinct answer. 4.17. In the year 1996, what is the difference between the Population (in %) of Heavily indebted poor countries and Population (in %) of Mozambique?
Provide a short and direct response. 0.76. In the year 1996, what is the difference between the Population (in %) in Bulgaria and Population (in %) in Gabon?
Your response must be concise. -24.19. In the year 1996, what is the difference between the Population (in %) of Bulgaria and Population (in %) of Mozambique?
Your answer should be very brief. -27.6. In the year 1996, what is the difference between the Population (in %) of Gabon and Population (in %) of Mozambique?
Give a very brief answer. -3.41. In the year 1997, what is the difference between the Population (in %) of Heavily indebted poor countries and Population (in %) of Bulgaria?
Your answer should be compact. 28.78. In the year 1997, what is the difference between the Population (in %) of Heavily indebted poor countries and Population (in %) of Gabon?
Ensure brevity in your answer.  4.3. In the year 1997, what is the difference between the Population (in %) of Heavily indebted poor countries and Population (in %) of Mozambique?
Make the answer very short. 0.7. In the year 1997, what is the difference between the Population (in %) of Bulgaria and Population (in %) of Gabon?
Provide a short and direct response. -24.48. In the year 1997, what is the difference between the Population (in %) in Bulgaria and Population (in %) in Mozambique?
Your response must be concise. -28.08. In the year 1997, what is the difference between the Population (in %) of Gabon and Population (in %) of Mozambique?
Offer a terse response. -3.6. In the year 1998, what is the difference between the Population (in %) of Heavily indebted poor countries and Population (in %) of Bulgaria?
Keep it short and to the point. 29.11. In the year 1998, what is the difference between the Population (in %) in Heavily indebted poor countries and Population (in %) in Gabon?
Your answer should be compact. 4.44. In the year 1998, what is the difference between the Population (in %) of Heavily indebted poor countries and Population (in %) of Mozambique?
Provide a short and direct response. 0.67. In the year 1998, what is the difference between the Population (in %) of Bulgaria and Population (in %) of Gabon?
Provide a short and direct response. -24.67. In the year 1998, what is the difference between the Population (in %) in Bulgaria and Population (in %) in Mozambique?
Provide a succinct answer. -28.45. In the year 1998, what is the difference between the Population (in %) of Gabon and Population (in %) of Mozambique?
Offer a very short reply. -3.77. In the year 1999, what is the difference between the Population (in %) in Heavily indebted poor countries and Population (in %) in Bulgaria?
Provide a short and direct response. 29.45. In the year 1999, what is the difference between the Population (in %) of Heavily indebted poor countries and Population (in %) of Gabon?
Offer a terse response. 4.61. In the year 1999, what is the difference between the Population (in %) in Heavily indebted poor countries and Population (in %) in Mozambique?
Make the answer very short. 0.62. In the year 1999, what is the difference between the Population (in %) of Bulgaria and Population (in %) of Gabon?
Your answer should be very brief. -24.84. In the year 1999, what is the difference between the Population (in %) of Bulgaria and Population (in %) of Mozambique?
Offer a terse response. -28.83. In the year 1999, what is the difference between the Population (in %) in Gabon and Population (in %) in Mozambique?
Provide a succinct answer. -3.98. In the year 2000, what is the difference between the Population (in %) in Heavily indebted poor countries and Population (in %) in Bulgaria?
Your answer should be compact. 29.81. In the year 2000, what is the difference between the Population (in %) of Heavily indebted poor countries and Population (in %) of Gabon?
Provide a short and direct response. 4.79. In the year 2000, what is the difference between the Population (in %) in Heavily indebted poor countries and Population (in %) in Mozambique?
Make the answer very short. 0.53. In the year 2000, what is the difference between the Population (in %) in Bulgaria and Population (in %) in Gabon?
Ensure brevity in your answer.  -25.01. In the year 2000, what is the difference between the Population (in %) in Bulgaria and Population (in %) in Mozambique?
Offer a very short reply. -29.27. In the year 2000, what is the difference between the Population (in %) in Gabon and Population (in %) in Mozambique?
Keep it short and to the point. -4.26. What is the ratio of the Population (in %) of Heavily indebted poor countries in 1993 to that in 1994?
Provide a succinct answer. 1. What is the ratio of the Population (in %) of Bulgaria in 1993 to that in 1994?
Your answer should be compact. 1.03. What is the ratio of the Population (in %) of Gabon in 1993 to that in 1994?
Provide a short and direct response. 1. What is the ratio of the Population (in %) in Mozambique in 1993 to that in 1994?
Ensure brevity in your answer.  1.01. What is the ratio of the Population (in %) in Heavily indebted poor countries in 1993 to that in 1995?
Your response must be concise. 1.01. What is the ratio of the Population (in %) in Bulgaria in 1993 to that in 1995?
Your answer should be compact. 1.06. What is the ratio of the Population (in %) in Mozambique in 1993 to that in 1995?
Offer a very short reply. 1.02. What is the ratio of the Population (in %) in Bulgaria in 1993 to that in 1996?
Ensure brevity in your answer.  1.09. What is the ratio of the Population (in %) in Gabon in 1993 to that in 1996?
Make the answer very short. 1.01. What is the ratio of the Population (in %) of Mozambique in 1993 to that in 1996?
Offer a terse response. 1.01. What is the ratio of the Population (in %) of Heavily indebted poor countries in 1993 to that in 1997?
Your answer should be compact. 1.01. What is the ratio of the Population (in %) in Bulgaria in 1993 to that in 1997?
Keep it short and to the point. 1.12. What is the ratio of the Population (in %) of Gabon in 1993 to that in 1997?
Provide a succinct answer. 1.01. What is the ratio of the Population (in %) in Bulgaria in 1993 to that in 1998?
Offer a very short reply. 1.15. What is the ratio of the Population (in %) of Mozambique in 1993 to that in 1998?
Offer a very short reply. 1.01. What is the ratio of the Population (in %) of Heavily indebted poor countries in 1993 to that in 1999?
Your answer should be very brief. 1.01. What is the ratio of the Population (in %) of Bulgaria in 1993 to that in 1999?
Make the answer very short. 1.18. What is the ratio of the Population (in %) of Mozambique in 1993 to that in 1999?
Provide a short and direct response. 1.01. What is the ratio of the Population (in %) in Heavily indebted poor countries in 1993 to that in 2000?
Ensure brevity in your answer.  1.01. What is the ratio of the Population (in %) in Bulgaria in 1993 to that in 2000?
Make the answer very short. 1.21. What is the ratio of the Population (in %) in Gabon in 1993 to that in 2000?
Offer a terse response. 1.03. What is the ratio of the Population (in %) of Mozambique in 1993 to that in 2000?
Offer a very short reply. 1.01. What is the ratio of the Population (in %) in Bulgaria in 1994 to that in 1995?
Offer a very short reply. 1.03. What is the ratio of the Population (in %) of Gabon in 1994 to that in 1995?
Offer a very short reply. 1. What is the ratio of the Population (in %) in Mozambique in 1994 to that in 1995?
Offer a terse response. 1.01. What is the ratio of the Population (in %) in Heavily indebted poor countries in 1994 to that in 1996?
Offer a terse response. 1. What is the ratio of the Population (in %) in Bulgaria in 1994 to that in 1996?
Your answer should be compact. 1.06. What is the ratio of the Population (in %) in Gabon in 1994 to that in 1996?
Make the answer very short. 1. What is the ratio of the Population (in %) in Heavily indebted poor countries in 1994 to that in 1997?
Your answer should be very brief. 1. What is the ratio of the Population (in %) of Bulgaria in 1994 to that in 1997?
Offer a terse response. 1.09. What is the ratio of the Population (in %) in Gabon in 1994 to that in 1997?
Make the answer very short. 1.01. What is the ratio of the Population (in %) of Bulgaria in 1994 to that in 1998?
Give a very brief answer. 1.11. What is the ratio of the Population (in %) in Gabon in 1994 to that in 1998?
Provide a short and direct response. 1.01. What is the ratio of the Population (in %) of Heavily indebted poor countries in 1994 to that in 1999?
Give a very brief answer. 1.01. What is the ratio of the Population (in %) in Bulgaria in 1994 to that in 1999?
Make the answer very short. 1.14. What is the ratio of the Population (in %) of Gabon in 1994 to that in 1999?
Keep it short and to the point. 1.02. What is the ratio of the Population (in %) of Mozambique in 1994 to that in 1999?
Your answer should be compact. 1.01. What is the ratio of the Population (in %) of Heavily indebted poor countries in 1994 to that in 2000?
Keep it short and to the point. 1.01. What is the ratio of the Population (in %) of Bulgaria in 1994 to that in 2000?
Provide a succinct answer. 1.17. What is the ratio of the Population (in %) of Gabon in 1994 to that in 2000?
Your answer should be compact. 1.03. What is the ratio of the Population (in %) in Bulgaria in 1995 to that in 1996?
Offer a terse response. 1.03. What is the ratio of the Population (in %) in Gabon in 1995 to that in 1996?
Give a very brief answer. 1. What is the ratio of the Population (in %) in Mozambique in 1995 to that in 1996?
Make the answer very short. 1. What is the ratio of the Population (in %) in Bulgaria in 1995 to that in 1997?
Your answer should be very brief. 1.06. What is the ratio of the Population (in %) of Heavily indebted poor countries in 1995 to that in 1998?
Provide a short and direct response. 1. What is the ratio of the Population (in %) of Bulgaria in 1995 to that in 1998?
Provide a succinct answer. 1.08. What is the ratio of the Population (in %) of Gabon in 1995 to that in 1998?
Keep it short and to the point. 1.01. What is the ratio of the Population (in %) in Mozambique in 1995 to that in 1998?
Your answer should be very brief. 1. What is the ratio of the Population (in %) in Bulgaria in 1995 to that in 1999?
Offer a terse response. 1.11. What is the ratio of the Population (in %) in Gabon in 1995 to that in 1999?
Provide a succinct answer. 1.02. What is the ratio of the Population (in %) in Mozambique in 1995 to that in 1999?
Give a very brief answer. 1. What is the ratio of the Population (in %) of Bulgaria in 1995 to that in 2000?
Your response must be concise. 1.14. What is the ratio of the Population (in %) in Gabon in 1995 to that in 2000?
Your answer should be very brief. 1.02. What is the ratio of the Population (in %) in Bulgaria in 1996 to that in 1997?
Offer a terse response. 1.03. What is the ratio of the Population (in %) in Mozambique in 1996 to that in 1997?
Your response must be concise. 1. What is the ratio of the Population (in %) in Heavily indebted poor countries in 1996 to that in 1998?
Provide a short and direct response. 1. What is the ratio of the Population (in %) in Bulgaria in 1996 to that in 1998?
Your response must be concise. 1.05. What is the ratio of the Population (in %) of Gabon in 1996 to that in 1998?
Ensure brevity in your answer.  1.01. What is the ratio of the Population (in %) of Gabon in 1996 to that in 1999?
Give a very brief answer. 1.01. What is the ratio of the Population (in %) in Heavily indebted poor countries in 1996 to that in 2000?
Your response must be concise. 1.01. What is the ratio of the Population (in %) of Bulgaria in 1996 to that in 2000?
Provide a short and direct response. 1.11. What is the ratio of the Population (in %) in Gabon in 1996 to that in 2000?
Make the answer very short. 1.02. What is the ratio of the Population (in %) in Mozambique in 1996 to that in 2000?
Your answer should be very brief. 1. What is the ratio of the Population (in %) in Bulgaria in 1997 to that in 1998?
Provide a short and direct response. 1.02. What is the ratio of the Population (in %) of Mozambique in 1997 to that in 1998?
Give a very brief answer. 1. What is the ratio of the Population (in %) in Heavily indebted poor countries in 1997 to that in 1999?
Your answer should be compact. 1. What is the ratio of the Population (in %) in Bulgaria in 1997 to that in 1999?
Your answer should be very brief. 1.05. What is the ratio of the Population (in %) in Gabon in 1997 to that in 1999?
Offer a very short reply. 1.01. What is the ratio of the Population (in %) of Bulgaria in 1997 to that in 2000?
Keep it short and to the point. 1.08. What is the ratio of the Population (in %) of Gabon in 1997 to that in 2000?
Offer a terse response. 1.02. What is the ratio of the Population (in %) in Mozambique in 1997 to that in 2000?
Make the answer very short. 1. What is the ratio of the Population (in %) in Bulgaria in 1998 to that in 1999?
Provide a succinct answer. 1.03. What is the ratio of the Population (in %) in Gabon in 1998 to that in 1999?
Offer a terse response. 1.01. What is the ratio of the Population (in %) in Heavily indebted poor countries in 1998 to that in 2000?
Make the answer very short. 1. What is the ratio of the Population (in %) of Bulgaria in 1998 to that in 2000?
Give a very brief answer. 1.06. What is the ratio of the Population (in %) in Gabon in 1998 to that in 2000?
Offer a very short reply. 1.01. What is the ratio of the Population (in %) in Mozambique in 1998 to that in 2000?
Offer a very short reply. 1. What is the ratio of the Population (in %) of Heavily indebted poor countries in 1999 to that in 2000?
Offer a terse response. 1. What is the ratio of the Population (in %) of Bulgaria in 1999 to that in 2000?
Your answer should be very brief. 1.03. What is the ratio of the Population (in %) in Gabon in 1999 to that in 2000?
Your response must be concise. 1.01. What is the ratio of the Population (in %) in Mozambique in 1999 to that in 2000?
Your response must be concise. 1. What is the difference between the highest and the second highest Population (in %) of Heavily indebted poor countries?
Your response must be concise. 0.11. What is the difference between the highest and the second highest Population (in %) of Bulgaria?
Ensure brevity in your answer.  0.56. What is the difference between the highest and the second highest Population (in %) of Gabon?
Ensure brevity in your answer.  0.03. What is the difference between the highest and the second highest Population (in %) of Mozambique?
Ensure brevity in your answer.  0.39. What is the difference between the highest and the lowest Population (in %) of Heavily indebted poor countries?
Provide a short and direct response. 0.47. What is the difference between the highest and the lowest Population (in %) of Bulgaria?
Your answer should be very brief. 3.29. What is the difference between the highest and the lowest Population (in %) in Gabon?
Keep it short and to the point. 1.11. What is the difference between the highest and the lowest Population (in %) in Mozambique?
Your answer should be compact. 0.75. 